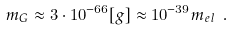Convert formula to latex. <formula><loc_0><loc_0><loc_500><loc_500>m _ { G } \approx 3 \cdot 1 0 ^ { - 6 6 } [ g ] \approx 1 0 ^ { - 3 9 } m _ { e l } \ .</formula> 